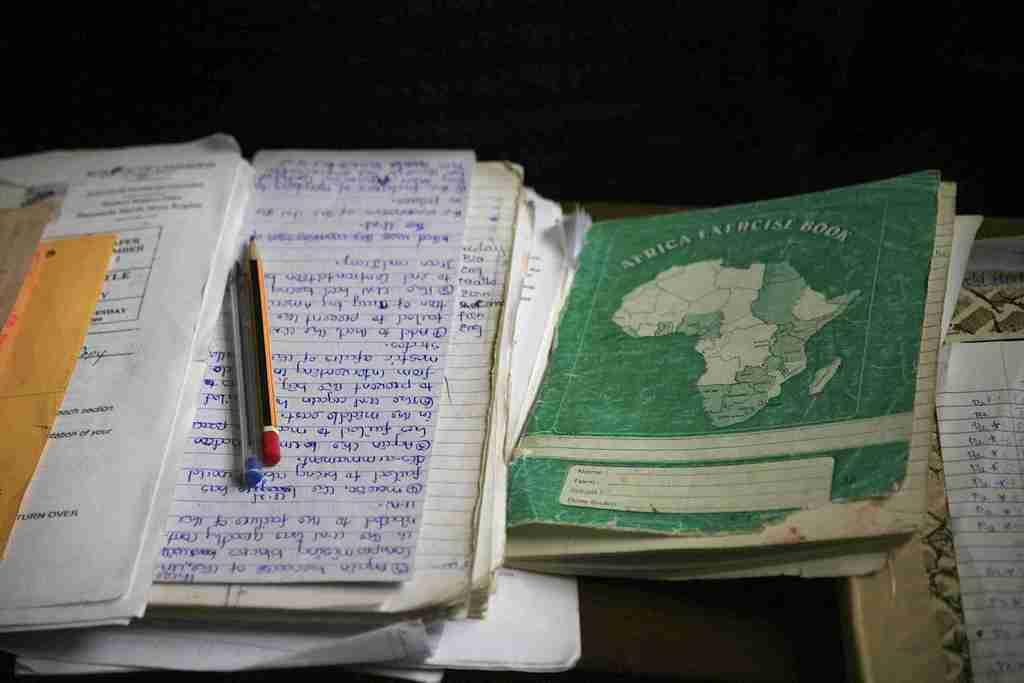Provide a one-sentence caption for the provided image. a green Africa Exercise Book next to other paper. 